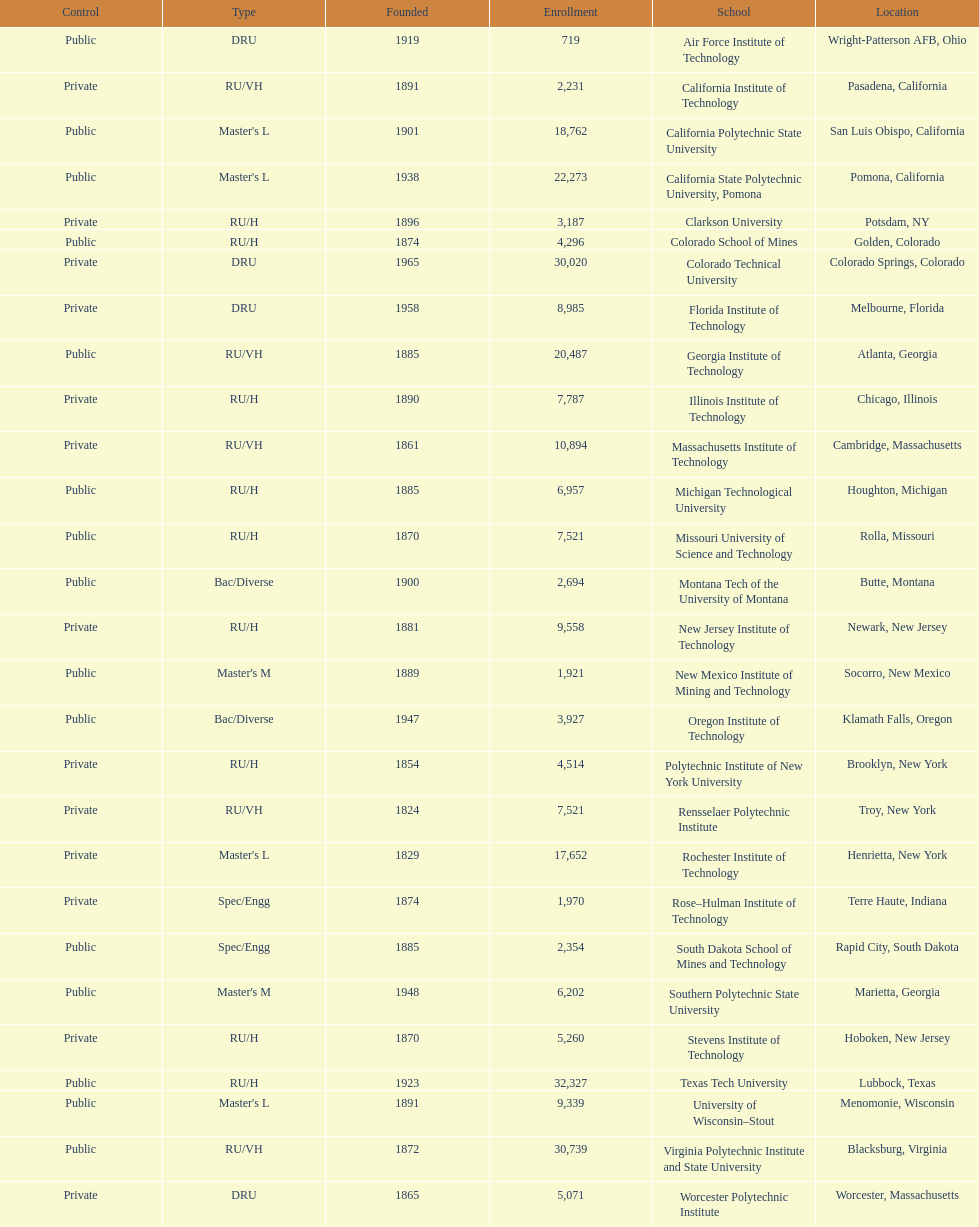What is the difference in enrollment between the top 2 schools listed in the table? 1512. 